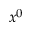<formula> <loc_0><loc_0><loc_500><loc_500>x ^ { 0 }</formula> 